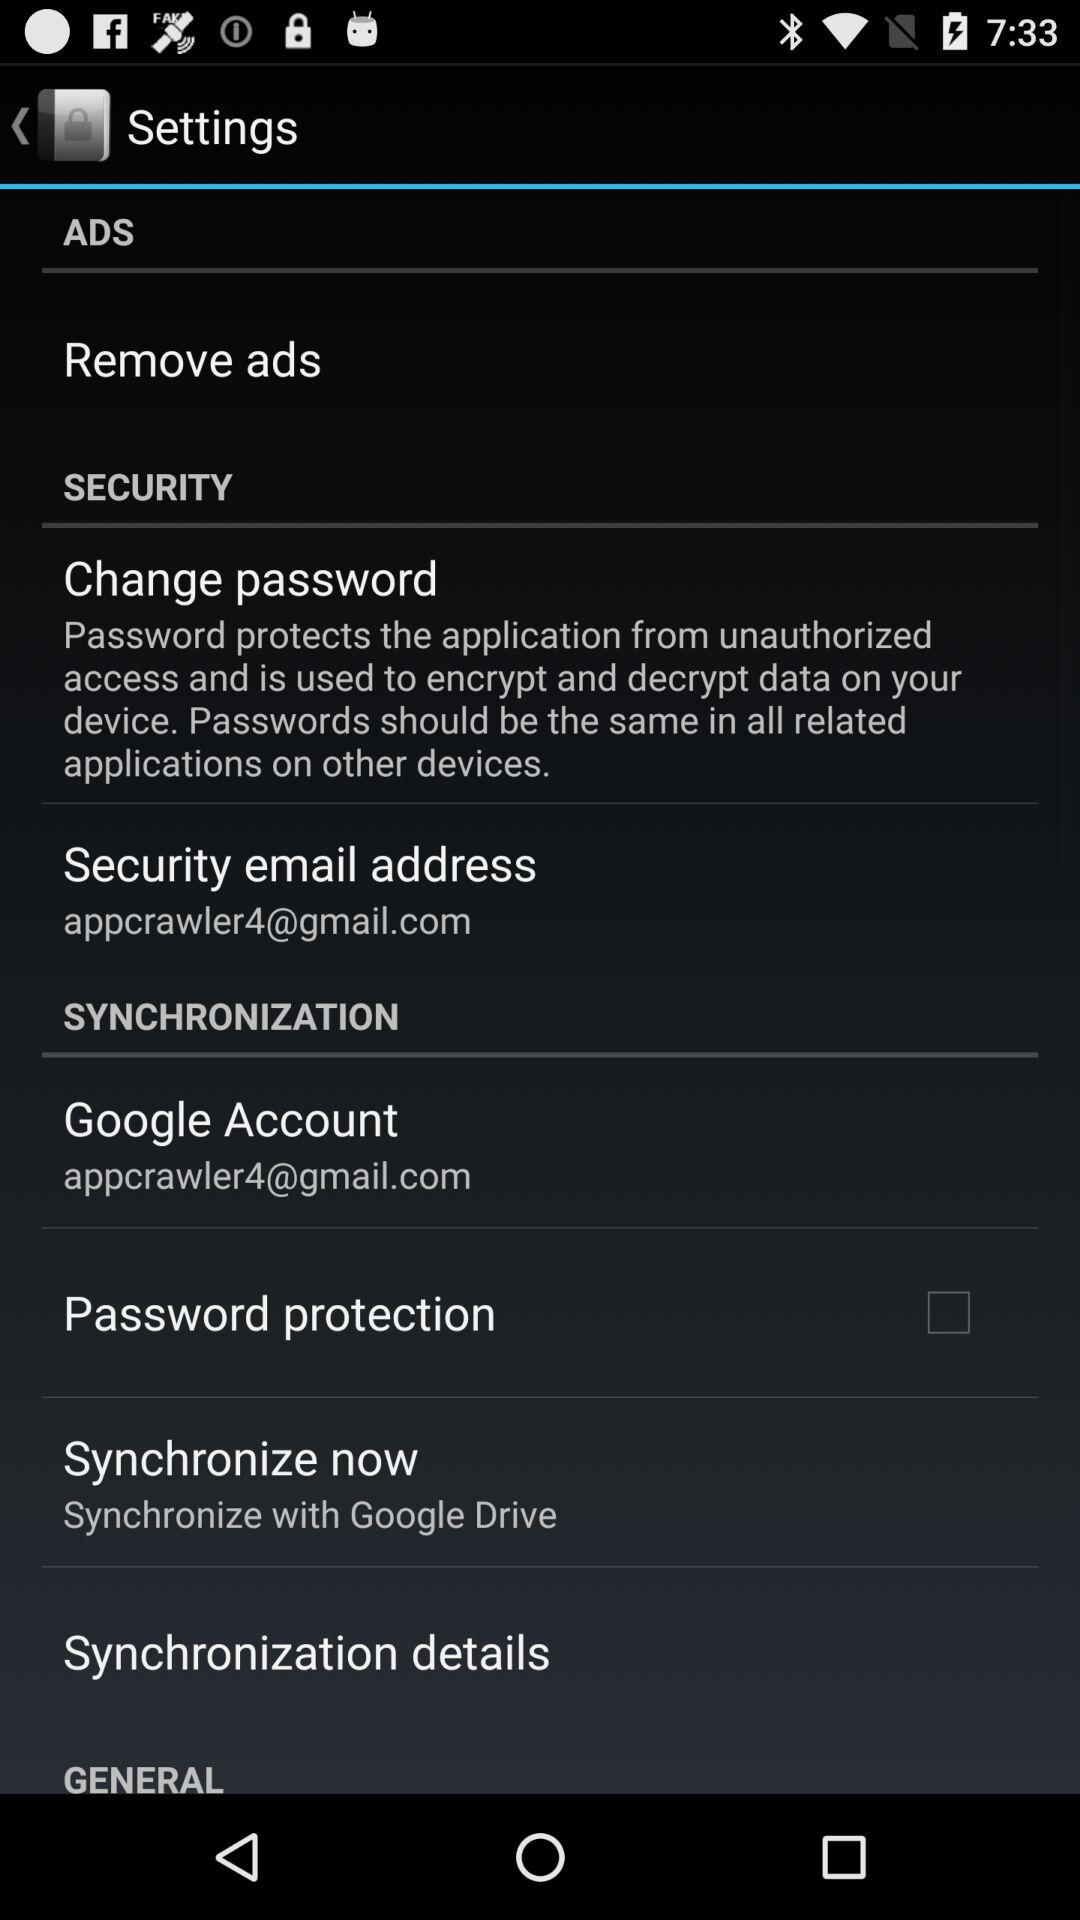What is the security email address? The security email address is appcrawler4@gmail.com. 